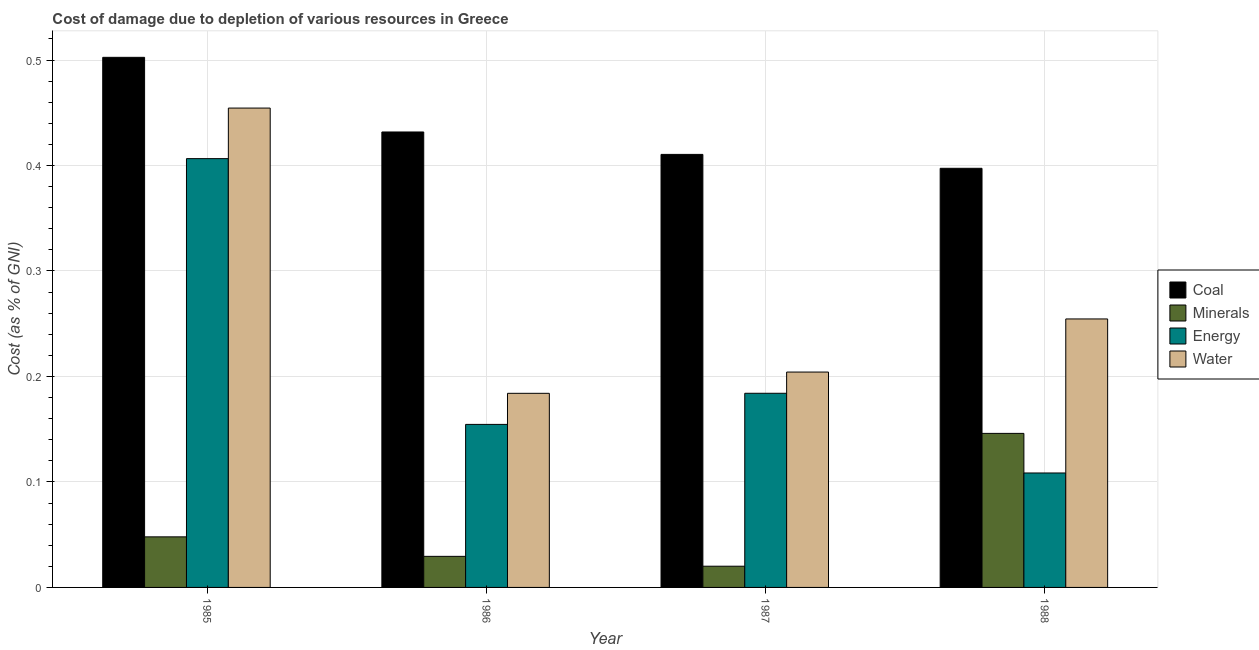How many bars are there on the 3rd tick from the left?
Keep it short and to the point. 4. How many bars are there on the 4th tick from the right?
Your response must be concise. 4. In how many cases, is the number of bars for a given year not equal to the number of legend labels?
Give a very brief answer. 0. What is the cost of damage due to depletion of water in 1987?
Give a very brief answer. 0.2. Across all years, what is the maximum cost of damage due to depletion of energy?
Your response must be concise. 0.41. Across all years, what is the minimum cost of damage due to depletion of energy?
Keep it short and to the point. 0.11. What is the total cost of damage due to depletion of water in the graph?
Make the answer very short. 1.1. What is the difference between the cost of damage due to depletion of minerals in 1986 and that in 1988?
Offer a very short reply. -0.12. What is the difference between the cost of damage due to depletion of water in 1985 and the cost of damage due to depletion of energy in 1988?
Offer a terse response. 0.2. What is the average cost of damage due to depletion of minerals per year?
Ensure brevity in your answer.  0.06. In how many years, is the cost of damage due to depletion of minerals greater than 0.12000000000000001 %?
Your answer should be compact. 1. What is the ratio of the cost of damage due to depletion of coal in 1985 to that in 1988?
Offer a terse response. 1.26. Is the cost of damage due to depletion of energy in 1987 less than that in 1988?
Provide a short and direct response. No. What is the difference between the highest and the second highest cost of damage due to depletion of water?
Offer a terse response. 0.2. What is the difference between the highest and the lowest cost of damage due to depletion of energy?
Provide a short and direct response. 0.3. In how many years, is the cost of damage due to depletion of water greater than the average cost of damage due to depletion of water taken over all years?
Provide a short and direct response. 1. Is the sum of the cost of damage due to depletion of coal in 1986 and 1988 greater than the maximum cost of damage due to depletion of water across all years?
Give a very brief answer. Yes. What does the 4th bar from the left in 1985 represents?
Offer a terse response. Water. What does the 1st bar from the right in 1987 represents?
Give a very brief answer. Water. How many bars are there?
Make the answer very short. 16. How many years are there in the graph?
Keep it short and to the point. 4. What is the difference between two consecutive major ticks on the Y-axis?
Give a very brief answer. 0.1. Are the values on the major ticks of Y-axis written in scientific E-notation?
Keep it short and to the point. No. Where does the legend appear in the graph?
Provide a short and direct response. Center right. How many legend labels are there?
Make the answer very short. 4. How are the legend labels stacked?
Keep it short and to the point. Vertical. What is the title of the graph?
Keep it short and to the point. Cost of damage due to depletion of various resources in Greece . What is the label or title of the X-axis?
Provide a succinct answer. Year. What is the label or title of the Y-axis?
Keep it short and to the point. Cost (as % of GNI). What is the Cost (as % of GNI) of Coal in 1985?
Keep it short and to the point. 0.5. What is the Cost (as % of GNI) in Minerals in 1985?
Make the answer very short. 0.05. What is the Cost (as % of GNI) in Energy in 1985?
Keep it short and to the point. 0.41. What is the Cost (as % of GNI) in Water in 1985?
Your response must be concise. 0.45. What is the Cost (as % of GNI) of Coal in 1986?
Provide a short and direct response. 0.43. What is the Cost (as % of GNI) in Minerals in 1986?
Make the answer very short. 0.03. What is the Cost (as % of GNI) of Energy in 1986?
Provide a succinct answer. 0.15. What is the Cost (as % of GNI) in Water in 1986?
Offer a terse response. 0.18. What is the Cost (as % of GNI) of Coal in 1987?
Ensure brevity in your answer.  0.41. What is the Cost (as % of GNI) in Minerals in 1987?
Give a very brief answer. 0.02. What is the Cost (as % of GNI) of Energy in 1987?
Offer a very short reply. 0.18. What is the Cost (as % of GNI) of Water in 1987?
Your answer should be compact. 0.2. What is the Cost (as % of GNI) in Coal in 1988?
Provide a short and direct response. 0.4. What is the Cost (as % of GNI) of Minerals in 1988?
Make the answer very short. 0.15. What is the Cost (as % of GNI) of Energy in 1988?
Provide a short and direct response. 0.11. What is the Cost (as % of GNI) in Water in 1988?
Offer a very short reply. 0.25. Across all years, what is the maximum Cost (as % of GNI) of Coal?
Offer a very short reply. 0.5. Across all years, what is the maximum Cost (as % of GNI) of Minerals?
Your response must be concise. 0.15. Across all years, what is the maximum Cost (as % of GNI) of Energy?
Provide a succinct answer. 0.41. Across all years, what is the maximum Cost (as % of GNI) of Water?
Make the answer very short. 0.45. Across all years, what is the minimum Cost (as % of GNI) of Coal?
Keep it short and to the point. 0.4. Across all years, what is the minimum Cost (as % of GNI) in Minerals?
Provide a succinct answer. 0.02. Across all years, what is the minimum Cost (as % of GNI) in Energy?
Make the answer very short. 0.11. Across all years, what is the minimum Cost (as % of GNI) in Water?
Offer a very short reply. 0.18. What is the total Cost (as % of GNI) of Coal in the graph?
Your answer should be compact. 1.74. What is the total Cost (as % of GNI) in Minerals in the graph?
Keep it short and to the point. 0.24. What is the total Cost (as % of GNI) of Energy in the graph?
Ensure brevity in your answer.  0.85. What is the total Cost (as % of GNI) of Water in the graph?
Your response must be concise. 1.1. What is the difference between the Cost (as % of GNI) of Coal in 1985 and that in 1986?
Your answer should be compact. 0.07. What is the difference between the Cost (as % of GNI) in Minerals in 1985 and that in 1986?
Ensure brevity in your answer.  0.02. What is the difference between the Cost (as % of GNI) in Energy in 1985 and that in 1986?
Your answer should be very brief. 0.25. What is the difference between the Cost (as % of GNI) of Water in 1985 and that in 1986?
Your response must be concise. 0.27. What is the difference between the Cost (as % of GNI) of Coal in 1985 and that in 1987?
Your answer should be very brief. 0.09. What is the difference between the Cost (as % of GNI) of Minerals in 1985 and that in 1987?
Your answer should be compact. 0.03. What is the difference between the Cost (as % of GNI) of Energy in 1985 and that in 1987?
Offer a terse response. 0.22. What is the difference between the Cost (as % of GNI) of Water in 1985 and that in 1987?
Your answer should be compact. 0.25. What is the difference between the Cost (as % of GNI) in Coal in 1985 and that in 1988?
Make the answer very short. 0.11. What is the difference between the Cost (as % of GNI) in Minerals in 1985 and that in 1988?
Offer a very short reply. -0.1. What is the difference between the Cost (as % of GNI) in Energy in 1985 and that in 1988?
Offer a very short reply. 0.3. What is the difference between the Cost (as % of GNI) in Water in 1985 and that in 1988?
Offer a very short reply. 0.2. What is the difference between the Cost (as % of GNI) of Coal in 1986 and that in 1987?
Your answer should be compact. 0.02. What is the difference between the Cost (as % of GNI) of Minerals in 1986 and that in 1987?
Your answer should be very brief. 0.01. What is the difference between the Cost (as % of GNI) in Energy in 1986 and that in 1987?
Ensure brevity in your answer.  -0.03. What is the difference between the Cost (as % of GNI) of Water in 1986 and that in 1987?
Provide a short and direct response. -0.02. What is the difference between the Cost (as % of GNI) of Coal in 1986 and that in 1988?
Make the answer very short. 0.03. What is the difference between the Cost (as % of GNI) of Minerals in 1986 and that in 1988?
Offer a terse response. -0.12. What is the difference between the Cost (as % of GNI) of Energy in 1986 and that in 1988?
Ensure brevity in your answer.  0.05. What is the difference between the Cost (as % of GNI) in Water in 1986 and that in 1988?
Provide a succinct answer. -0.07. What is the difference between the Cost (as % of GNI) in Coal in 1987 and that in 1988?
Give a very brief answer. 0.01. What is the difference between the Cost (as % of GNI) of Minerals in 1987 and that in 1988?
Offer a very short reply. -0.13. What is the difference between the Cost (as % of GNI) of Energy in 1987 and that in 1988?
Ensure brevity in your answer.  0.08. What is the difference between the Cost (as % of GNI) of Water in 1987 and that in 1988?
Provide a succinct answer. -0.05. What is the difference between the Cost (as % of GNI) in Coal in 1985 and the Cost (as % of GNI) in Minerals in 1986?
Your response must be concise. 0.47. What is the difference between the Cost (as % of GNI) of Coal in 1985 and the Cost (as % of GNI) of Energy in 1986?
Your answer should be compact. 0.35. What is the difference between the Cost (as % of GNI) of Coal in 1985 and the Cost (as % of GNI) of Water in 1986?
Ensure brevity in your answer.  0.32. What is the difference between the Cost (as % of GNI) of Minerals in 1985 and the Cost (as % of GNI) of Energy in 1986?
Offer a terse response. -0.11. What is the difference between the Cost (as % of GNI) of Minerals in 1985 and the Cost (as % of GNI) of Water in 1986?
Offer a very short reply. -0.14. What is the difference between the Cost (as % of GNI) in Energy in 1985 and the Cost (as % of GNI) in Water in 1986?
Provide a succinct answer. 0.22. What is the difference between the Cost (as % of GNI) of Coal in 1985 and the Cost (as % of GNI) of Minerals in 1987?
Provide a succinct answer. 0.48. What is the difference between the Cost (as % of GNI) of Coal in 1985 and the Cost (as % of GNI) of Energy in 1987?
Provide a succinct answer. 0.32. What is the difference between the Cost (as % of GNI) in Coal in 1985 and the Cost (as % of GNI) in Water in 1987?
Give a very brief answer. 0.3. What is the difference between the Cost (as % of GNI) in Minerals in 1985 and the Cost (as % of GNI) in Energy in 1987?
Give a very brief answer. -0.14. What is the difference between the Cost (as % of GNI) of Minerals in 1985 and the Cost (as % of GNI) of Water in 1987?
Provide a short and direct response. -0.16. What is the difference between the Cost (as % of GNI) of Energy in 1985 and the Cost (as % of GNI) of Water in 1987?
Give a very brief answer. 0.2. What is the difference between the Cost (as % of GNI) of Coal in 1985 and the Cost (as % of GNI) of Minerals in 1988?
Provide a short and direct response. 0.36. What is the difference between the Cost (as % of GNI) in Coal in 1985 and the Cost (as % of GNI) in Energy in 1988?
Make the answer very short. 0.39. What is the difference between the Cost (as % of GNI) in Coal in 1985 and the Cost (as % of GNI) in Water in 1988?
Your answer should be very brief. 0.25. What is the difference between the Cost (as % of GNI) in Minerals in 1985 and the Cost (as % of GNI) in Energy in 1988?
Make the answer very short. -0.06. What is the difference between the Cost (as % of GNI) of Minerals in 1985 and the Cost (as % of GNI) of Water in 1988?
Ensure brevity in your answer.  -0.21. What is the difference between the Cost (as % of GNI) in Energy in 1985 and the Cost (as % of GNI) in Water in 1988?
Offer a terse response. 0.15. What is the difference between the Cost (as % of GNI) in Coal in 1986 and the Cost (as % of GNI) in Minerals in 1987?
Provide a short and direct response. 0.41. What is the difference between the Cost (as % of GNI) in Coal in 1986 and the Cost (as % of GNI) in Energy in 1987?
Your response must be concise. 0.25. What is the difference between the Cost (as % of GNI) in Coal in 1986 and the Cost (as % of GNI) in Water in 1987?
Make the answer very short. 0.23. What is the difference between the Cost (as % of GNI) of Minerals in 1986 and the Cost (as % of GNI) of Energy in 1987?
Your answer should be very brief. -0.15. What is the difference between the Cost (as % of GNI) in Minerals in 1986 and the Cost (as % of GNI) in Water in 1987?
Your response must be concise. -0.17. What is the difference between the Cost (as % of GNI) in Energy in 1986 and the Cost (as % of GNI) in Water in 1987?
Keep it short and to the point. -0.05. What is the difference between the Cost (as % of GNI) of Coal in 1986 and the Cost (as % of GNI) of Minerals in 1988?
Offer a terse response. 0.29. What is the difference between the Cost (as % of GNI) in Coal in 1986 and the Cost (as % of GNI) in Energy in 1988?
Your answer should be very brief. 0.32. What is the difference between the Cost (as % of GNI) in Coal in 1986 and the Cost (as % of GNI) in Water in 1988?
Offer a very short reply. 0.18. What is the difference between the Cost (as % of GNI) in Minerals in 1986 and the Cost (as % of GNI) in Energy in 1988?
Provide a succinct answer. -0.08. What is the difference between the Cost (as % of GNI) in Minerals in 1986 and the Cost (as % of GNI) in Water in 1988?
Provide a succinct answer. -0.23. What is the difference between the Cost (as % of GNI) in Coal in 1987 and the Cost (as % of GNI) in Minerals in 1988?
Your response must be concise. 0.26. What is the difference between the Cost (as % of GNI) in Coal in 1987 and the Cost (as % of GNI) in Energy in 1988?
Offer a very short reply. 0.3. What is the difference between the Cost (as % of GNI) of Coal in 1987 and the Cost (as % of GNI) of Water in 1988?
Ensure brevity in your answer.  0.16. What is the difference between the Cost (as % of GNI) in Minerals in 1987 and the Cost (as % of GNI) in Energy in 1988?
Your answer should be compact. -0.09. What is the difference between the Cost (as % of GNI) in Minerals in 1987 and the Cost (as % of GNI) in Water in 1988?
Give a very brief answer. -0.23. What is the difference between the Cost (as % of GNI) of Energy in 1987 and the Cost (as % of GNI) of Water in 1988?
Make the answer very short. -0.07. What is the average Cost (as % of GNI) in Coal per year?
Offer a very short reply. 0.44. What is the average Cost (as % of GNI) of Minerals per year?
Provide a short and direct response. 0.06. What is the average Cost (as % of GNI) in Energy per year?
Your answer should be very brief. 0.21. What is the average Cost (as % of GNI) in Water per year?
Offer a very short reply. 0.27. In the year 1985, what is the difference between the Cost (as % of GNI) of Coal and Cost (as % of GNI) of Minerals?
Your response must be concise. 0.45. In the year 1985, what is the difference between the Cost (as % of GNI) of Coal and Cost (as % of GNI) of Energy?
Your answer should be very brief. 0.1. In the year 1985, what is the difference between the Cost (as % of GNI) in Coal and Cost (as % of GNI) in Water?
Offer a very short reply. 0.05. In the year 1985, what is the difference between the Cost (as % of GNI) in Minerals and Cost (as % of GNI) in Energy?
Offer a terse response. -0.36. In the year 1985, what is the difference between the Cost (as % of GNI) of Minerals and Cost (as % of GNI) of Water?
Provide a short and direct response. -0.41. In the year 1985, what is the difference between the Cost (as % of GNI) in Energy and Cost (as % of GNI) in Water?
Provide a short and direct response. -0.05. In the year 1986, what is the difference between the Cost (as % of GNI) in Coal and Cost (as % of GNI) in Minerals?
Make the answer very short. 0.4. In the year 1986, what is the difference between the Cost (as % of GNI) in Coal and Cost (as % of GNI) in Energy?
Give a very brief answer. 0.28. In the year 1986, what is the difference between the Cost (as % of GNI) in Coal and Cost (as % of GNI) in Water?
Offer a very short reply. 0.25. In the year 1986, what is the difference between the Cost (as % of GNI) of Minerals and Cost (as % of GNI) of Energy?
Give a very brief answer. -0.13. In the year 1986, what is the difference between the Cost (as % of GNI) of Minerals and Cost (as % of GNI) of Water?
Provide a short and direct response. -0.15. In the year 1986, what is the difference between the Cost (as % of GNI) in Energy and Cost (as % of GNI) in Water?
Provide a short and direct response. -0.03. In the year 1987, what is the difference between the Cost (as % of GNI) in Coal and Cost (as % of GNI) in Minerals?
Your answer should be very brief. 0.39. In the year 1987, what is the difference between the Cost (as % of GNI) of Coal and Cost (as % of GNI) of Energy?
Make the answer very short. 0.23. In the year 1987, what is the difference between the Cost (as % of GNI) of Coal and Cost (as % of GNI) of Water?
Your answer should be very brief. 0.21. In the year 1987, what is the difference between the Cost (as % of GNI) of Minerals and Cost (as % of GNI) of Energy?
Give a very brief answer. -0.16. In the year 1987, what is the difference between the Cost (as % of GNI) of Minerals and Cost (as % of GNI) of Water?
Offer a very short reply. -0.18. In the year 1987, what is the difference between the Cost (as % of GNI) in Energy and Cost (as % of GNI) in Water?
Ensure brevity in your answer.  -0.02. In the year 1988, what is the difference between the Cost (as % of GNI) of Coal and Cost (as % of GNI) of Minerals?
Your answer should be very brief. 0.25. In the year 1988, what is the difference between the Cost (as % of GNI) in Coal and Cost (as % of GNI) in Energy?
Your response must be concise. 0.29. In the year 1988, what is the difference between the Cost (as % of GNI) of Coal and Cost (as % of GNI) of Water?
Your answer should be compact. 0.14. In the year 1988, what is the difference between the Cost (as % of GNI) of Minerals and Cost (as % of GNI) of Energy?
Your answer should be very brief. 0.04. In the year 1988, what is the difference between the Cost (as % of GNI) in Minerals and Cost (as % of GNI) in Water?
Your answer should be compact. -0.11. In the year 1988, what is the difference between the Cost (as % of GNI) in Energy and Cost (as % of GNI) in Water?
Provide a short and direct response. -0.15. What is the ratio of the Cost (as % of GNI) of Coal in 1985 to that in 1986?
Keep it short and to the point. 1.16. What is the ratio of the Cost (as % of GNI) of Minerals in 1985 to that in 1986?
Ensure brevity in your answer.  1.63. What is the ratio of the Cost (as % of GNI) of Energy in 1985 to that in 1986?
Provide a short and direct response. 2.63. What is the ratio of the Cost (as % of GNI) in Water in 1985 to that in 1986?
Make the answer very short. 2.47. What is the ratio of the Cost (as % of GNI) of Coal in 1985 to that in 1987?
Your response must be concise. 1.22. What is the ratio of the Cost (as % of GNI) in Minerals in 1985 to that in 1987?
Provide a short and direct response. 2.38. What is the ratio of the Cost (as % of GNI) in Energy in 1985 to that in 1987?
Your answer should be compact. 2.21. What is the ratio of the Cost (as % of GNI) of Water in 1985 to that in 1987?
Make the answer very short. 2.23. What is the ratio of the Cost (as % of GNI) in Coal in 1985 to that in 1988?
Provide a short and direct response. 1.26. What is the ratio of the Cost (as % of GNI) in Minerals in 1985 to that in 1988?
Ensure brevity in your answer.  0.33. What is the ratio of the Cost (as % of GNI) in Energy in 1985 to that in 1988?
Keep it short and to the point. 3.75. What is the ratio of the Cost (as % of GNI) in Water in 1985 to that in 1988?
Offer a terse response. 1.79. What is the ratio of the Cost (as % of GNI) of Coal in 1986 to that in 1987?
Provide a short and direct response. 1.05. What is the ratio of the Cost (as % of GNI) in Minerals in 1986 to that in 1987?
Your answer should be very brief. 1.46. What is the ratio of the Cost (as % of GNI) in Energy in 1986 to that in 1987?
Offer a terse response. 0.84. What is the ratio of the Cost (as % of GNI) in Water in 1986 to that in 1987?
Offer a terse response. 0.9. What is the ratio of the Cost (as % of GNI) of Coal in 1986 to that in 1988?
Your answer should be compact. 1.09. What is the ratio of the Cost (as % of GNI) in Minerals in 1986 to that in 1988?
Offer a very short reply. 0.2. What is the ratio of the Cost (as % of GNI) of Energy in 1986 to that in 1988?
Make the answer very short. 1.42. What is the ratio of the Cost (as % of GNI) in Water in 1986 to that in 1988?
Your answer should be very brief. 0.72. What is the ratio of the Cost (as % of GNI) in Coal in 1987 to that in 1988?
Your answer should be very brief. 1.03. What is the ratio of the Cost (as % of GNI) of Minerals in 1987 to that in 1988?
Provide a succinct answer. 0.14. What is the ratio of the Cost (as % of GNI) in Energy in 1987 to that in 1988?
Give a very brief answer. 1.7. What is the ratio of the Cost (as % of GNI) of Water in 1987 to that in 1988?
Provide a succinct answer. 0.8. What is the difference between the highest and the second highest Cost (as % of GNI) in Coal?
Ensure brevity in your answer.  0.07. What is the difference between the highest and the second highest Cost (as % of GNI) of Minerals?
Provide a succinct answer. 0.1. What is the difference between the highest and the second highest Cost (as % of GNI) of Energy?
Your answer should be compact. 0.22. What is the difference between the highest and the second highest Cost (as % of GNI) in Water?
Your response must be concise. 0.2. What is the difference between the highest and the lowest Cost (as % of GNI) of Coal?
Your response must be concise. 0.11. What is the difference between the highest and the lowest Cost (as % of GNI) in Minerals?
Keep it short and to the point. 0.13. What is the difference between the highest and the lowest Cost (as % of GNI) of Energy?
Keep it short and to the point. 0.3. What is the difference between the highest and the lowest Cost (as % of GNI) of Water?
Provide a succinct answer. 0.27. 